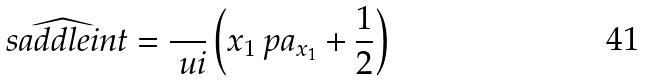<formula> <loc_0><loc_0><loc_500><loc_500>\widehat { \ s a d d l e i n t } = \frac { } { \ u i } \left ( x _ { 1 } \ p a _ { x _ { 1 } } + \frac { 1 } { 2 } \right )</formula> 